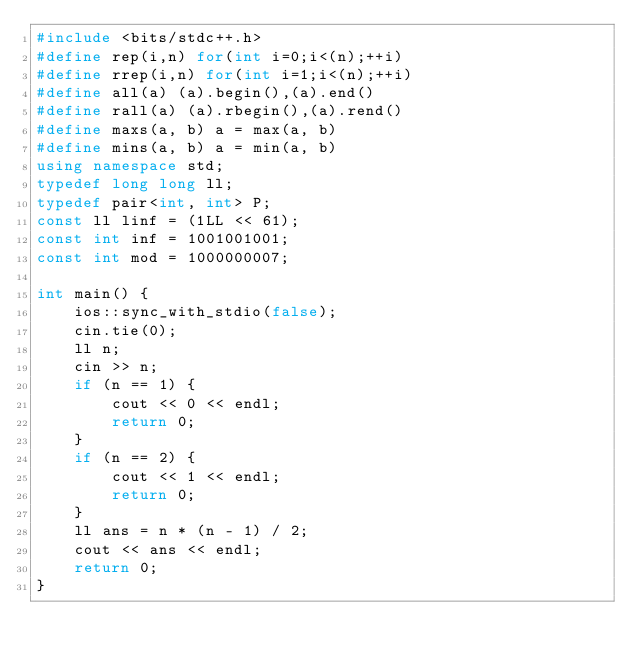<code> <loc_0><loc_0><loc_500><loc_500><_C++_>#include <bits/stdc++.h>
#define rep(i,n) for(int i=0;i<(n);++i)
#define rrep(i,n) for(int i=1;i<(n);++i)
#define all(a) (a).begin(),(a).end()
#define rall(a) (a).rbegin(),(a).rend()
#define maxs(a, b) a = max(a, b)
#define mins(a, b) a = min(a, b)
using namespace std;
typedef long long ll;
typedef pair<int, int> P;
const ll linf = (1LL << 61);
const int inf = 1001001001;
const int mod = 1000000007;

int main() {
	ios::sync_with_stdio(false);
	cin.tie(0);
	ll n;
	cin >> n;
	if (n == 1) {
		cout << 0 << endl;
		return 0;
	}
	if (n == 2) {
		cout << 1 << endl;
		return 0;
	}
	ll ans = n * (n - 1) / 2;
	cout << ans << endl;
	return 0;
}</code> 